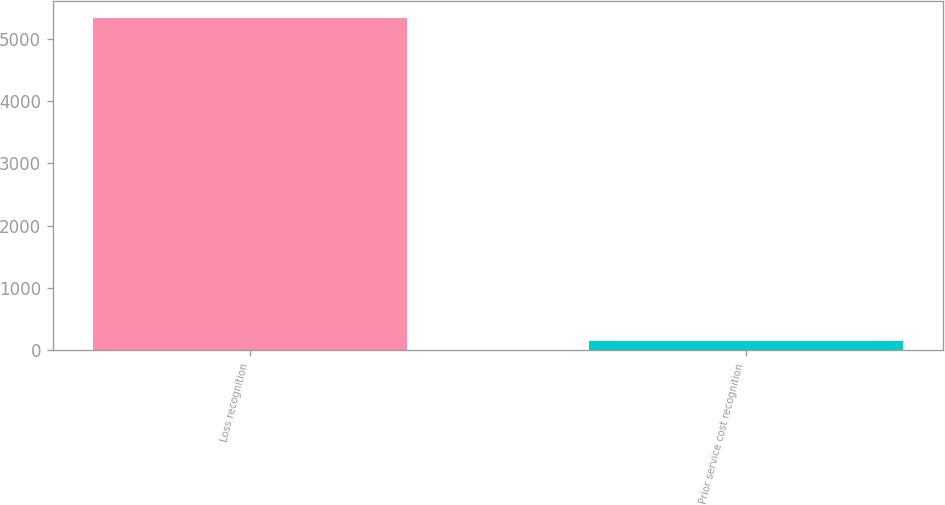Convert chart to OTSL. <chart><loc_0><loc_0><loc_500><loc_500><bar_chart><fcel>Loss recognition<fcel>Prior service cost recognition<nl><fcel>5330<fcel>145<nl></chart> 